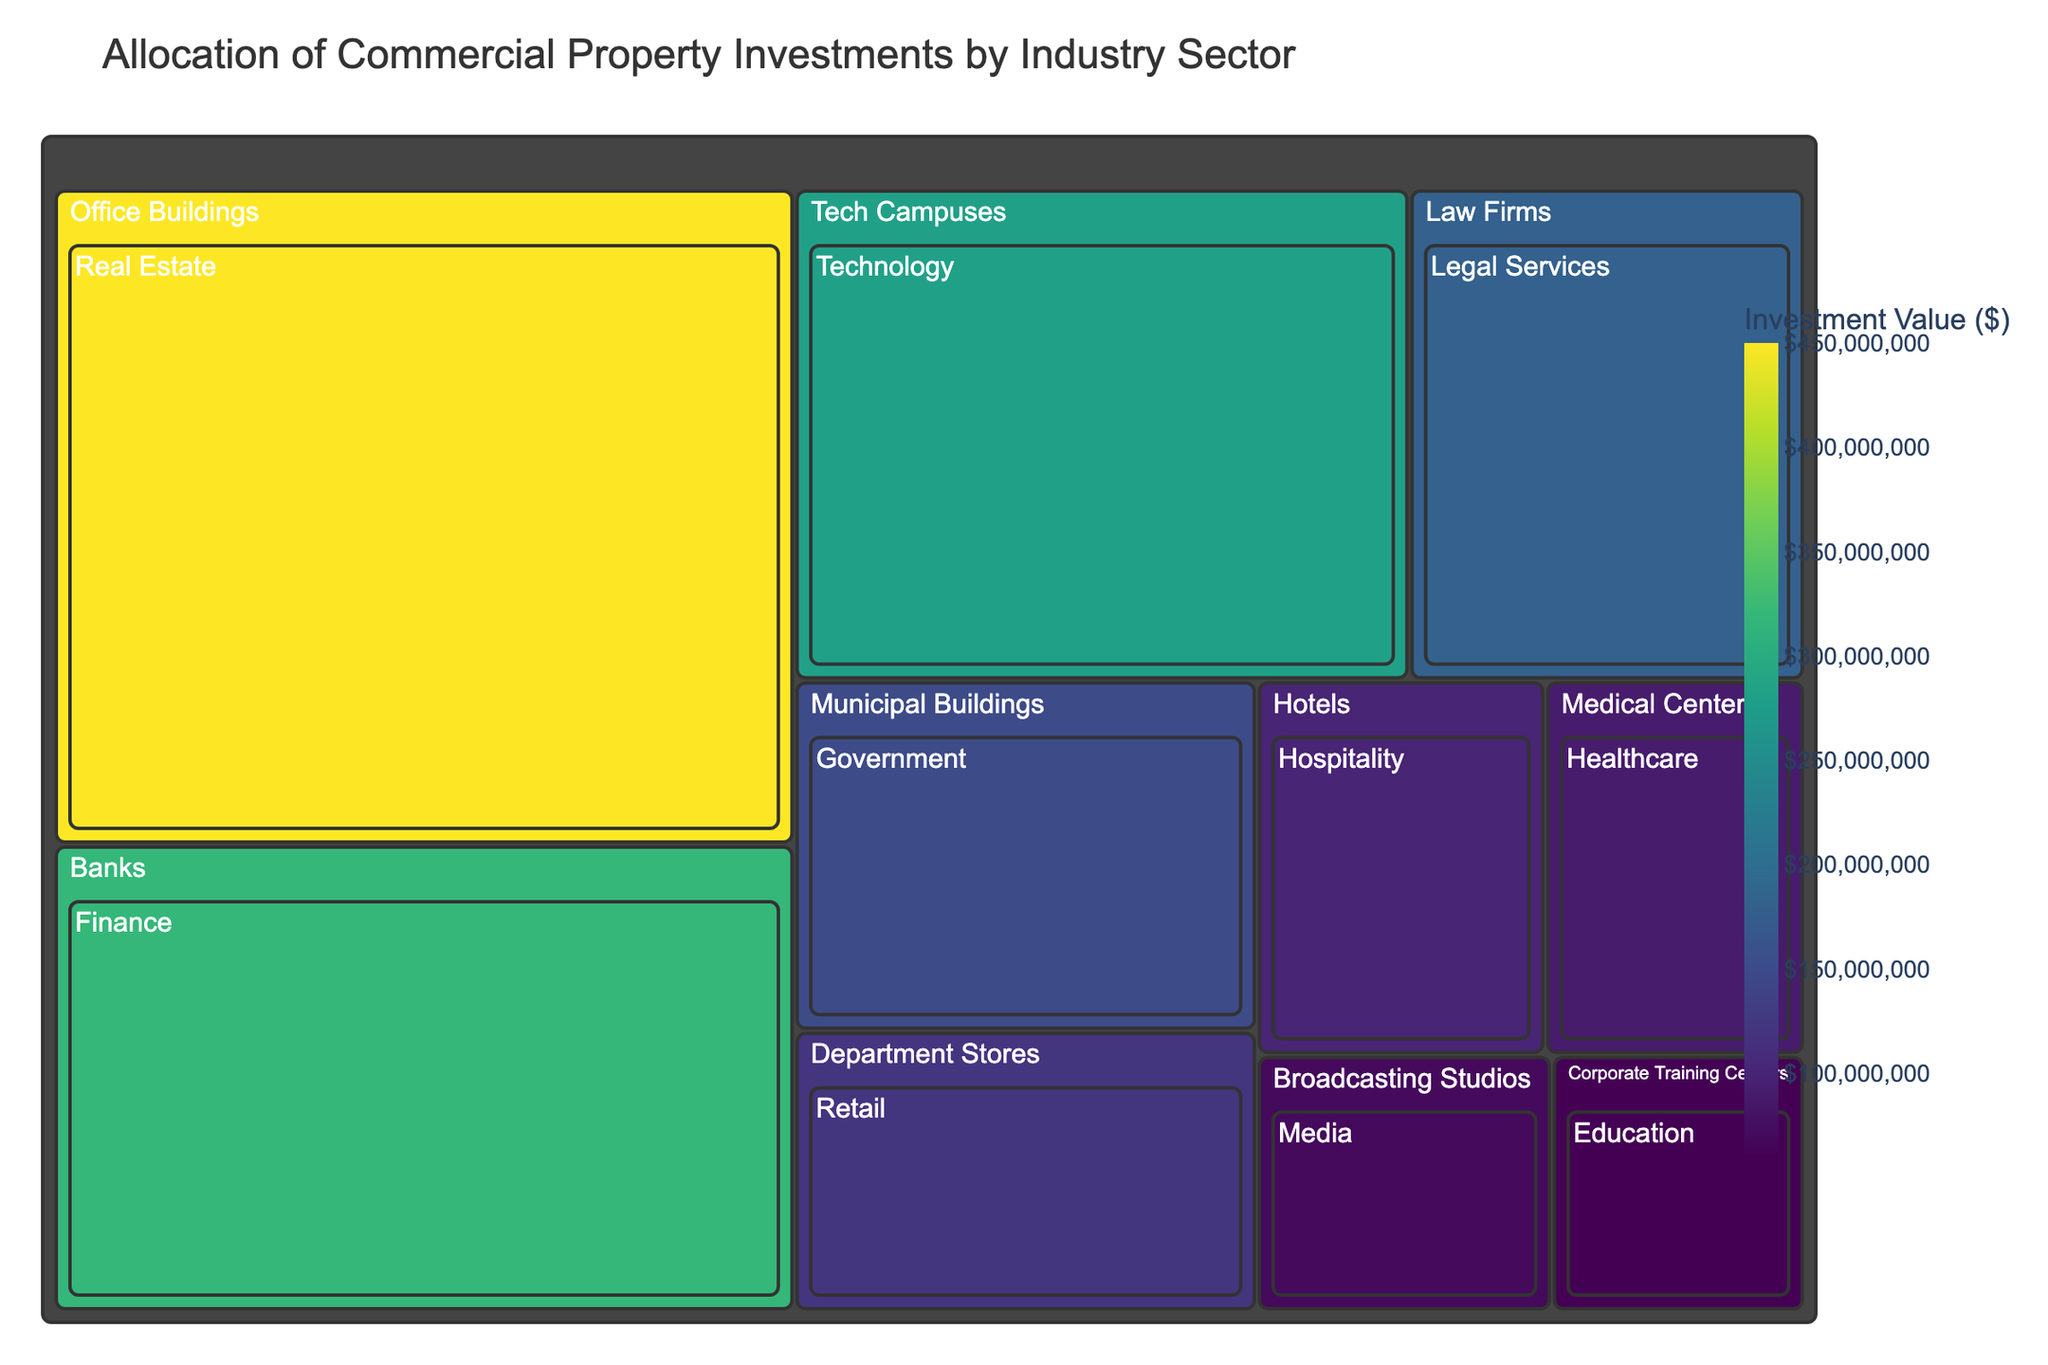What's the total investment in the Real Estate sector? To find the total investment in the Real Estate sector, locate the 'Real Estate' section on the treemap and refer to its displayed investment value.
Answer: $450,000,000 Which sector has the highest investment value and what is the amount? Identify the sector with the largest visual area and verify the investment value displayed within that section.
Answer: Office Buildings, $450,000,000 How much more investment does the Finance sector have compared to the Technology sector? Calculate the difference in investment values by subtracting the Technology sector’s investment value from the Finance sector’s investment value. $320,000,000 - $280,000,000 = $40,000,000.
Answer: $40,000,000 What percentage of the total investment is allocated to the Healthcare sector? First, sum all the investments: $450,000,000 + $320,000,000 + $280,000,000 + $180,000,000 + $150,000,000 + $120,000,000 + $100,000,000 + $90,000,000 + $70,000,000 + $60,000,000 = $1,820,000,000. Then, divide the Healthcare investment by the total and multiply by 100: ($90,000,000 / $1,820,000,000) * 100 ≈ 4.95%.
Answer: ≈ 4.95% Which sector has the least investment and what is the value? Locate the smallest section on the treemap and check the displayed investment value.
Answer: Corporate Training Centers, $60,000,000 Are the investments in the Retail and Hospitality sectors combined more than the investment in the Legal Services sector? Add the investments of the Retail and Hospitality sectors and compare it to the investment in the Legal Services sector. $120,000,000 (Retail) + $100,000,000 (Hospitality) = $220,000,000, which is greater than $180,000,000 (Legal Services).
Answer: Yes, $220,000,000 is greater than $180,000,000 Identify the industries within the Office Buildings sector and their individual investment values. Refer to the 'Office Buildings' sector in the treemap and list all the industries along with their respective investment values.
Answer: Real Estate, $450,000,000 Which sector has a larger investment: Government or Media? Compare the investment values of the Government and Media sectors by looking at their respective sections in the treemap.
Answer: Government, $150,000,000 What is the combined investment value for sectors associated with services (Legal Services, Healthcare, Education)? Sum the investment values of Legal Services, Healthcare, and Education sectors. $180,000,000 + $90,000,000 + $60,000,000 = $330,000,000.
Answer: $330,000,000 How does the investment in Financial sector Banks compare to that in Department Stores? Compare the investment values of the 'Banks' and 'Department Stores' sectors by locating their sections on the treemap.
Answer: Banks have more investment with $320,000,000 compared to $120,000,000 for Department Stores 